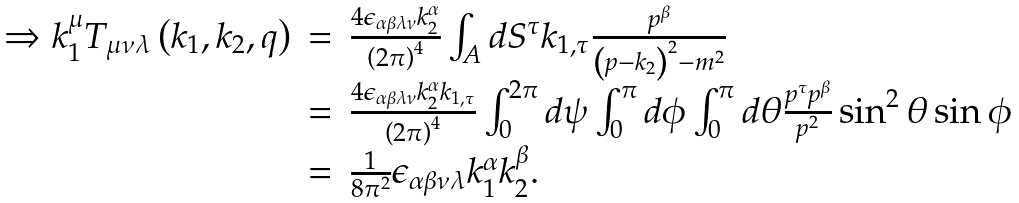Convert formula to latex. <formula><loc_0><loc_0><loc_500><loc_500>\begin{array} { r c l } \Rightarrow k _ { 1 } ^ { \mu } T _ { \mu \nu \lambda } \left ( k _ { 1 } , k _ { 2 } , q \right ) & = & \frac { 4 \epsilon _ { \alpha \beta \lambda \nu } k _ { 2 } ^ { \alpha } } { \left ( 2 \pi \right ) ^ { 4 } } \int _ { A } d S ^ { \tau } k _ { 1 , \tau } \frac { p ^ { \beta } } { \left ( p - k _ { 2 } \right ) ^ { 2 } - m ^ { 2 } } \\ & = & \frac { 4 \epsilon _ { \alpha \beta \lambda \nu } k _ { 2 } ^ { \alpha } k _ { 1 , \tau } } { \left ( 2 \pi \right ) ^ { 4 } } \int _ { 0 } ^ { 2 \pi } d \psi \int _ { 0 } ^ { \pi } d \phi \int _ { 0 } ^ { \pi } d \theta \frac { p ^ { \tau } p ^ { \beta } } { p ^ { 2 } } \sin ^ { 2 } \theta \sin \phi \\ & = & \frac { 1 } { 8 \pi ^ { 2 } } \epsilon _ { \alpha \beta \nu \lambda } k _ { 1 } ^ { \alpha } k _ { 2 } ^ { \beta } . \end{array}</formula> 